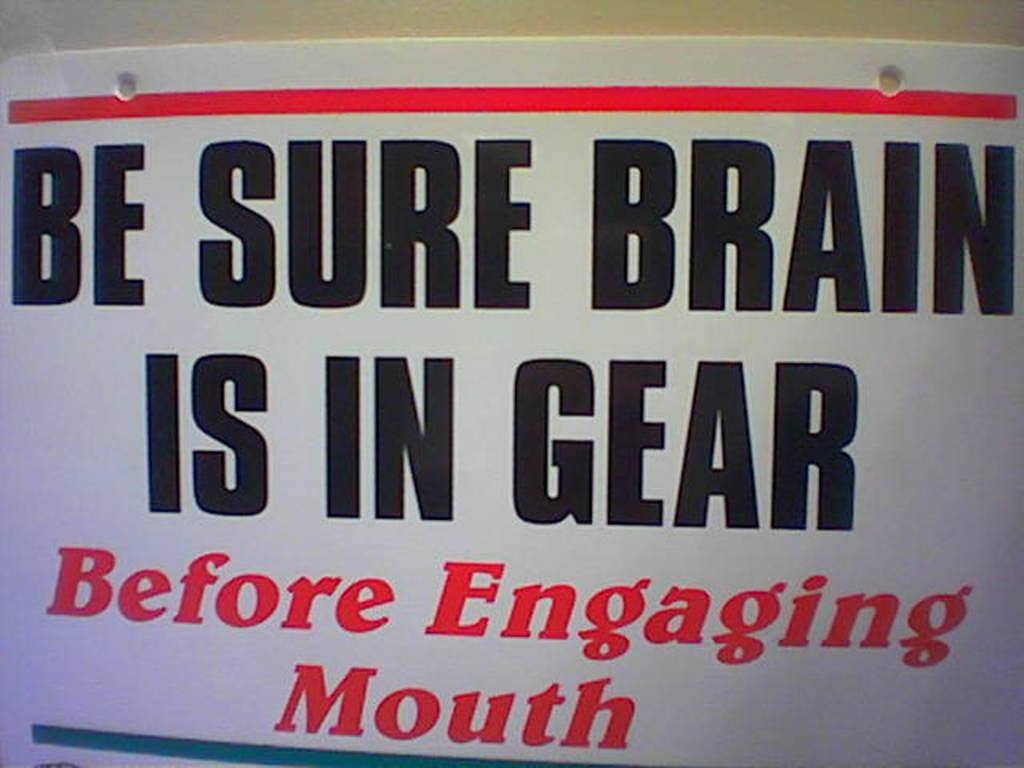<image>
Write a terse but informative summary of the picture. sign that reads be sure brain is in gear 